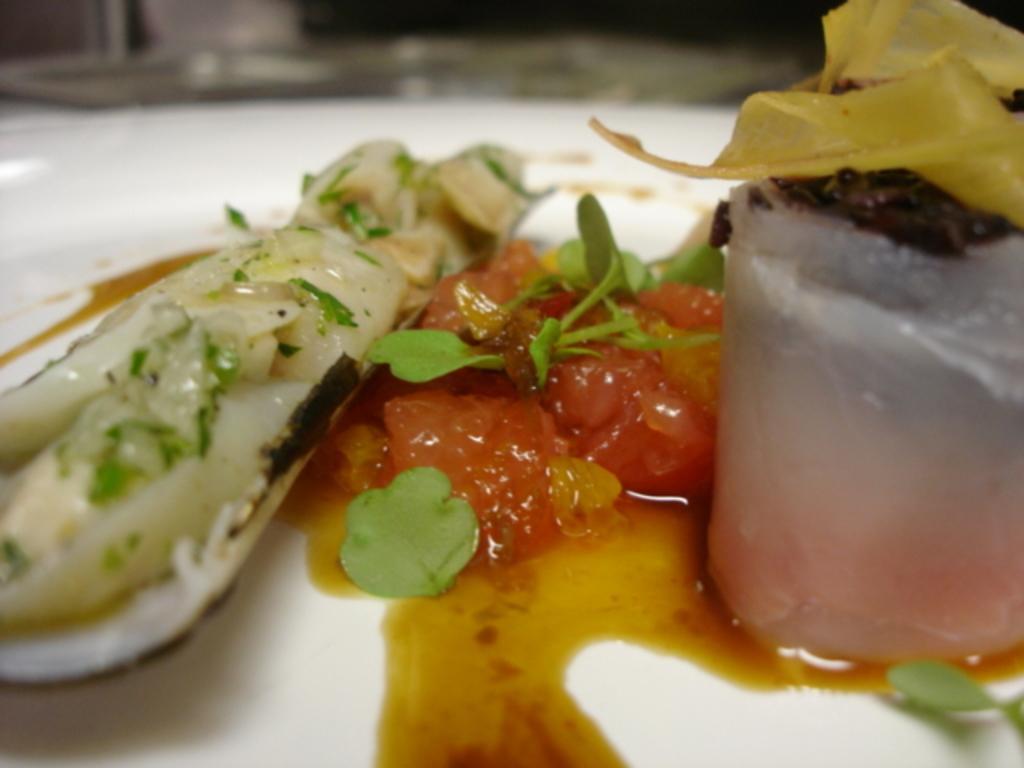How would you summarize this image in a sentence or two? In this image we can see food item is kept in a white color plate. 